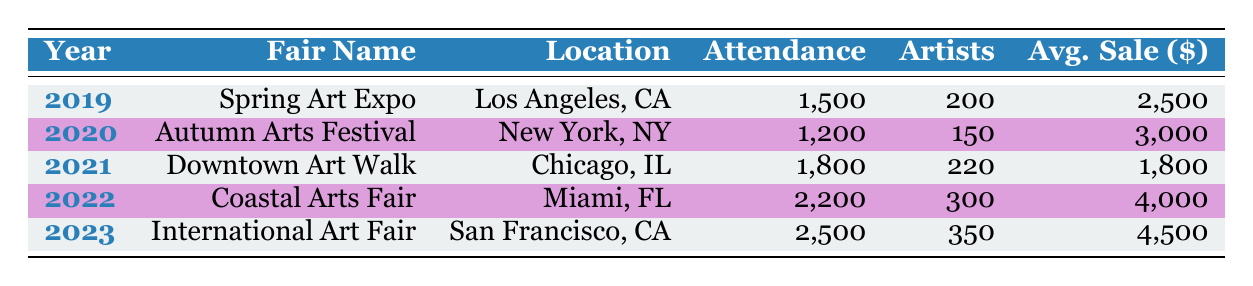What was the attendance at the Coastal Arts Fair in 2022? The attendance at the Coastal Arts Fair, which took place in 2022, is listed in the table. It states 2,200 for that year.
Answer: 2,200 Which art fair had the highest average sale per artist? By comparing the average sale per artist for each year, the International Art Fair in 2023 shows the highest average sale at 4,500.
Answer: 4,500 How many artists participated in the Autumn Arts Festival in 2020? The number of artists participating in the Autumn Arts Festival, which is shown in the table for the year 2020, is 150.
Answer: 150 Was the attendance at the Downtown Art Walk higher than that at the Spring Art Expo? Comparing the attendance values, the Downtown Art Walk (1,800) is greater than the Spring Art Expo (1,500). Therefore, the statement is true.
Answer: Yes What is the total attendance across all art fairs over the five years? To find the total attendance, we sum the attendance values: 1,500 + 1,200 + 1,800 + 2,200 + 2,500 = 9,200.
Answer: 9,200 How many more artists participated in the Coastal Arts Fair compared to the Downtown Art Walk? The Coastal Arts Fair had 300 artists, while the Downtown Art Walk had 220 artists. The difference is 300 - 220 = 80 more artists participated in the Coastal Arts Fair.
Answer: 80 In which year did the lowest attendance occur, and what was that attendance? Looking through the table, the lowest attendance is for the Autumn Arts Festival in 2020, with an attendance of 1,200.
Answer: 2020, 1,200 What is the average attendance across all five years? To find the average attendance, sum up the individual attendances: 1,500 + 1,200 + 1,800 + 2,200 + 2,500 = 9,200 and divide by 5 (the number of years): 9,200 / 5 = 1,840.
Answer: 1,840 Which location hosted the International Art Fair? The location for the International Art Fair, as given in the table for the year 2023, is San Francisco, CA.
Answer: San Francisco, CA 